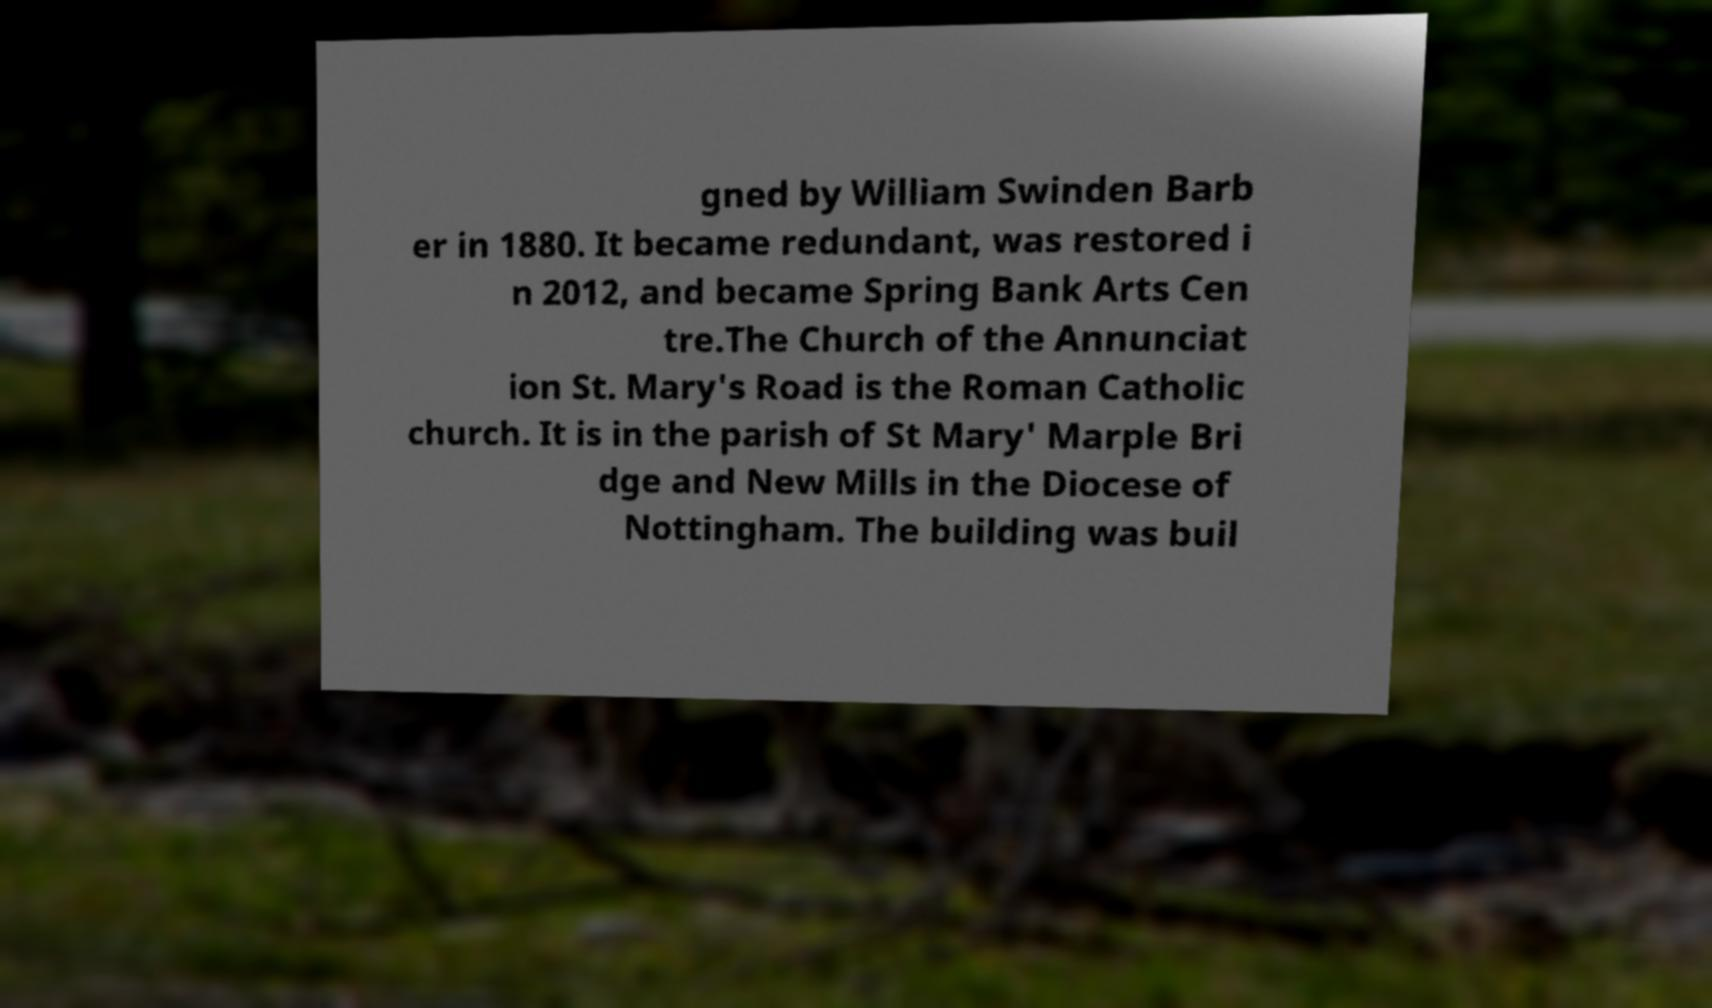I need the written content from this picture converted into text. Can you do that? gned by William Swinden Barb er in 1880. It became redundant, was restored i n 2012, and became Spring Bank Arts Cen tre.The Church of the Annunciat ion St. Mary's Road is the Roman Catholic church. It is in the parish of St Mary' Marple Bri dge and New Mills in the Diocese of Nottingham. The building was buil 